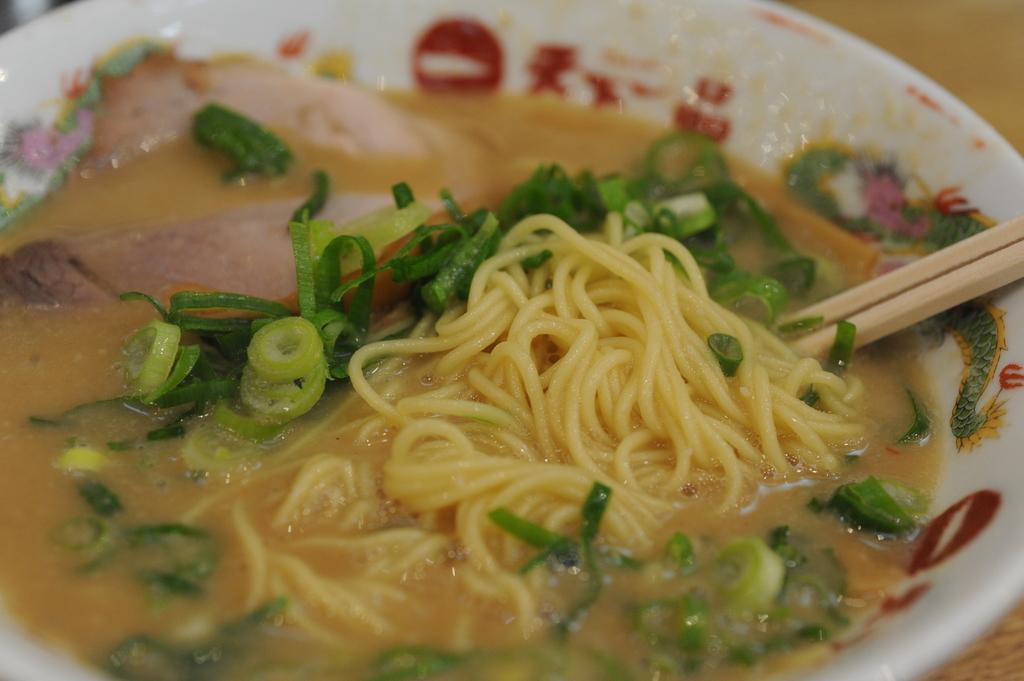Could you give a brief overview of what you see in this image? In the picture we can see some noodles, soup, some leafy vegetables in a bowl and chopsticks. 